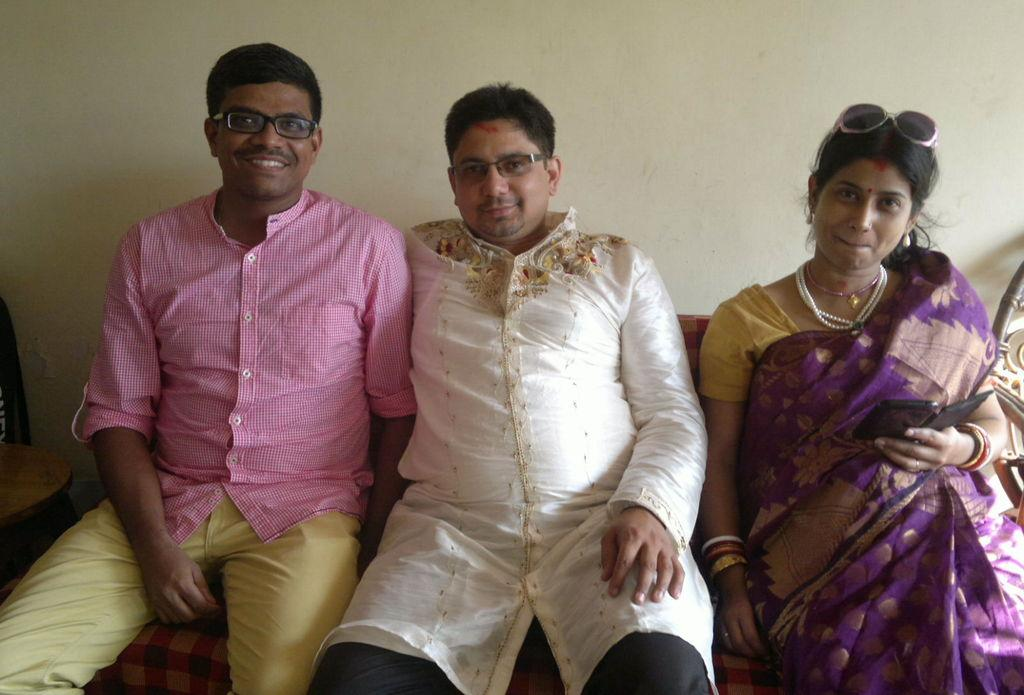What can be seen in the foreground of the image? There are people sitting in the foreground area of the image. What object is located on the left side of the image? There is a chair on the left side of the image. What is visible in the background of the image? There is a wall in the background of the image. Can you tell me how many cacti are growing on the wall in the image? There are no cacti visible on the wall in the image. What arithmetic problem are the people solving in the image? There is no indication of any arithmetic problem being solved in the image. Is there a donkey present in the image? There is no donkey visible in the image. 